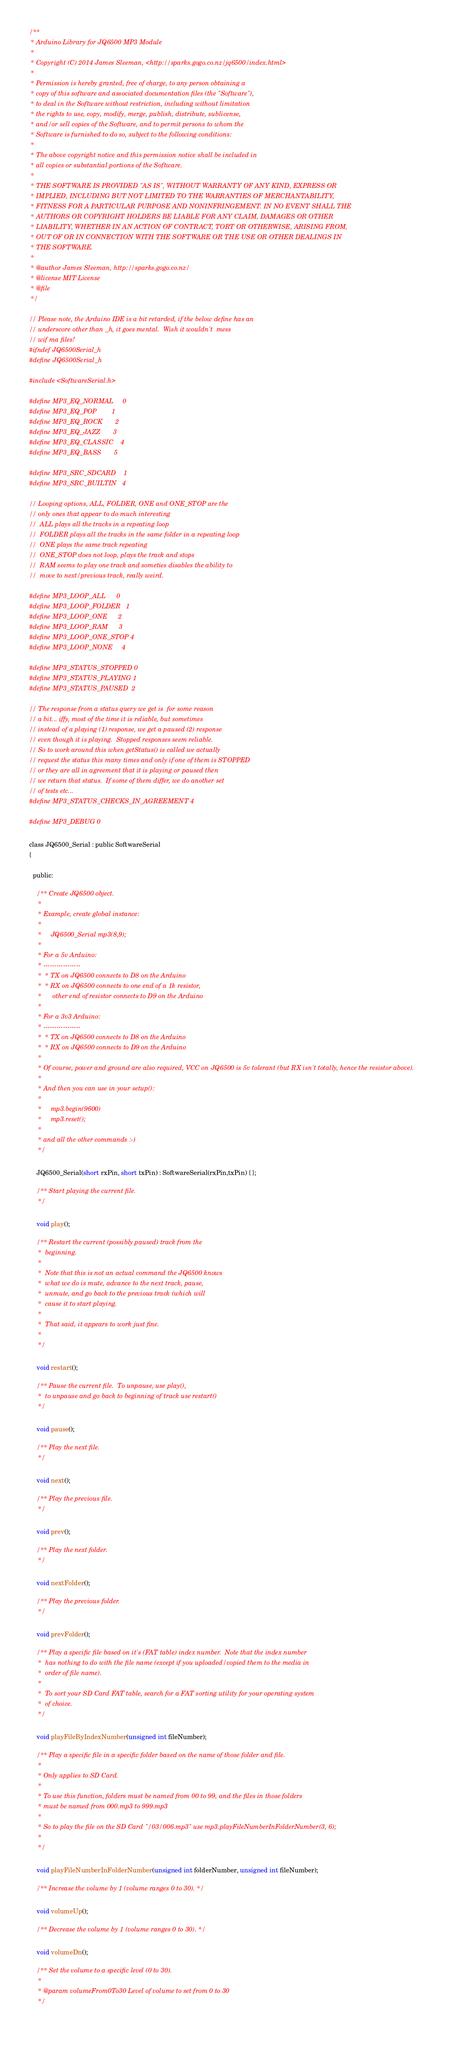Convert code to text. <code><loc_0><loc_0><loc_500><loc_500><_C_>/** 
 * Arduino Library for JQ6500 MP3 Module
 * 
 * Copyright (C) 2014 James Sleeman, <http://sparks.gogo.co.nz/jq6500/index.html>
 * 
 * Permission is hereby granted, free of charge, to any person obtaining a 
 * copy of this software and associated documentation files (the "Software"), 
 * to deal in the Software without restriction, including without limitation 
 * the rights to use, copy, modify, merge, publish, distribute, sublicense, 
 * and/or sell copies of the Software, and to permit persons to whom the 
 * Software is furnished to do so, subject to the following conditions:
 * 
 * The above copyright notice and this permission notice shall be included in 
 * all copies or substantial portions of the Software.
 * 
 * THE SOFTWARE IS PROVIDED "AS IS", WITHOUT WARRANTY OF ANY KIND, EXPRESS OR
 * IMPLIED, INCLUDING BUT NOT LIMITED TO THE WARRANTIES OF MERCHANTABILITY,
 * FITNESS FOR A PARTICULAR PURPOSE AND NONINFRINGEMENT. IN NO EVENT SHALL THE 
 * AUTHORS OR COPYRIGHT HOLDERS BE LIABLE FOR ANY CLAIM, DAMAGES OR OTHER 
 * LIABILITY, WHETHER IN AN ACTION OF CONTRACT, TORT OR OTHERWISE, ARISING FROM, 
 * OUT OF OR IN CONNECTION WITH THE SOFTWARE OR THE USE OR OTHER DEALINGS IN 
 * THE SOFTWARE.
 * 
 * @author James Sleeman, http://sparks.gogo.co.nz/
 * @license MIT License
 * @file
 */

// Please note, the Arduino IDE is a bit retarded, if the below define has an
// underscore other than _h, it goes mental.  Wish it wouldn't  mess
// wif ma files!
#ifndef JQ6500Serial_h
#define JQ6500Serial_h

#include <SoftwareSerial.h>

#define MP3_EQ_NORMAL     0
#define MP3_EQ_POP        1
#define MP3_EQ_ROCK       2
#define MP3_EQ_JAZZ       3
#define MP3_EQ_CLASSIC    4
#define MP3_EQ_BASS       5

#define MP3_SRC_SDCARD    1
#define MP3_SRC_BUILTIN   4

// Looping options, ALL, FOLDER, ONE and ONE_STOP are the 
// only ones that appear to do much interesting
//  ALL plays all the tracks in a repeating loop
//  FOLDER plays all the tracks in the same folder in a repeating loop
//  ONE plays the same track repeating
//  ONE_STOP does not loop, plays the track and stops
//  RAM seems to play one track and someties disables the ability to 
//  move to next/previous track, really weird.

#define MP3_LOOP_ALL      0
#define MP3_LOOP_FOLDER   1
#define MP3_LOOP_ONE      2
#define MP3_LOOP_RAM      3
#define MP3_LOOP_ONE_STOP 4
#define MP3_LOOP_NONE     4 

#define MP3_STATUS_STOPPED 0
#define MP3_STATUS_PLAYING 1
#define MP3_STATUS_PAUSED  2

// The response from a status query we get is  for some reason
// a bit... iffy, most of the time it is reliable, but sometimes
// instead of a playing (1) response, we get a paused (2) response
// even though it is playing.  Stopped responses seem reliable.
// So to work around this when getStatus() is called we actually
// request the status this many times and only if one of them is STOPPED
// or they are all in agreement that it is playing or paused then
// we return that status.  If some of them differ, we do another set 
// of tests etc...
#define MP3_STATUS_CHECKS_IN_AGREEMENT 4

#define MP3_DEBUG 0

class JQ6500_Serial : public SoftwareSerial
{
  
  public: 

    /** Create JQ6500 object.
     * 
     * Example, create global instance:
     * 
     *     JQ6500_Serial mp3(8,9);
     * 
     * For a 5v Arduino:
     * -----------------
     *  * TX on JQ6500 connects to D8 on the Arduino
     *  * RX on JQ6500 connects to one end of a 1k resistor,
     *      other end of resistor connects to D9 on the Arduino
     * 
     * For a 3v3 Arduino:
     * -----------------
     *  * TX on JQ6500 connects to D8 on the Arduino
     *  * RX on JQ6500 connects to D9 on the Arduino
     * 
     * Of course, power and ground are also required, VCC on JQ6500 is 5v tolerant (but RX isn't totally, hence the resistor above).
     * 
     * And then you can use in your setup():
     * 
     *     mp3.begin(9600)
     *     mp3.reset();
     *
     * and all the other commands :-)
     */
    
    JQ6500_Serial(short rxPin, short txPin) : SoftwareSerial(rxPin,txPin) { };
    
    /** Start playing the current file.
     */
    
    void play();
    
    /** Restart the current (possibly paused) track from the 
     *  beginning.
     *  
     *  Note that this is not an actual command the JQ6500 knows
     *  what we do is mute, advance to the next track, pause,
     *  unmute, and go back to the previous track (which will
     *  cause it to start playing.
     * 
     *  That said, it appears to work just fine.
     * 
     */
    
    void restart();
    
    /** Pause the current file.  To unpause, use play(),
     *  to unpause and go back to beginning of track use restart()
     */
    
    void pause();
    
    /** Play the next file.
     */
    
    void next();
    
    /** Play the previous file.
     */
    
    void prev();
    
    /** Play the next folder. 
     */
    
    void nextFolder();
    
    /** Play the previous folder. 
     */
    
    void prevFolder();
    
    /** Play a specific file based on it's (FAT table) index number.  Note that the index number
     *  has nothing to do with the file name (except if you uploaded/copied them to the media in
     *  order of file name).
     * 
     *  To sort your SD Card FAT table, search for a FAT sorting utility for your operating system 
     *  of choice.
     */
    
    void playFileByIndexNumber(unsigned int fileNumber);        
    
    /** Play a specific file in a specific folder based on the name of those folder and file.
     * 
     * Only applies to SD Card.
     * 
     * To use this function, folders must be named from 00 to 99, and the files in those folders
     * must be named from 000.mp3 to 999.mp3
     * 
     * So to play the file on the SD Card "/03/006.mp3" use mp3.playFileNumberInFolderNumber(3, 6);
     * 
     */
    
    void playFileNumberInFolderNumber(unsigned int folderNumber, unsigned int fileNumber);
    
    /** Increase the volume by 1 (volume ranges 0 to 30). */
    
    void volumeUp();
    
    /** Decrease the volume by 1 (volume ranges 0 to 30). */
    
    void volumeDn();
    
    /** Set the volume to a specific level (0 to 30). 
     * 
     * @param volumeFrom0To30 Level of volume to set from 0 to 30
     */
    </code> 